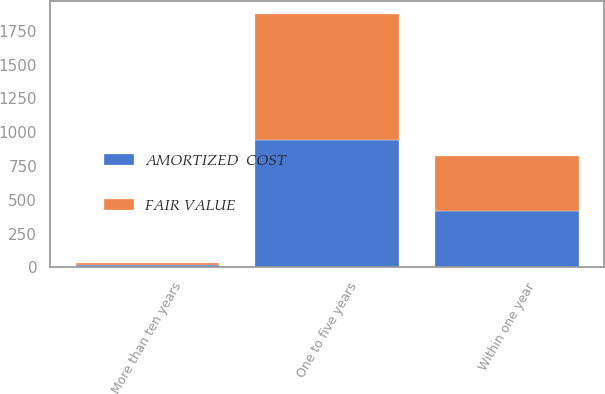<chart> <loc_0><loc_0><loc_500><loc_500><stacked_bar_chart><ecel><fcel>Within one year<fcel>One to five years<fcel>More than ten years<nl><fcel>AMORTIZED  COST<fcel>413.7<fcel>939.6<fcel>16.9<nl><fcel>FAIR VALUE<fcel>413.3<fcel>936.9<fcel>16.9<nl></chart> 